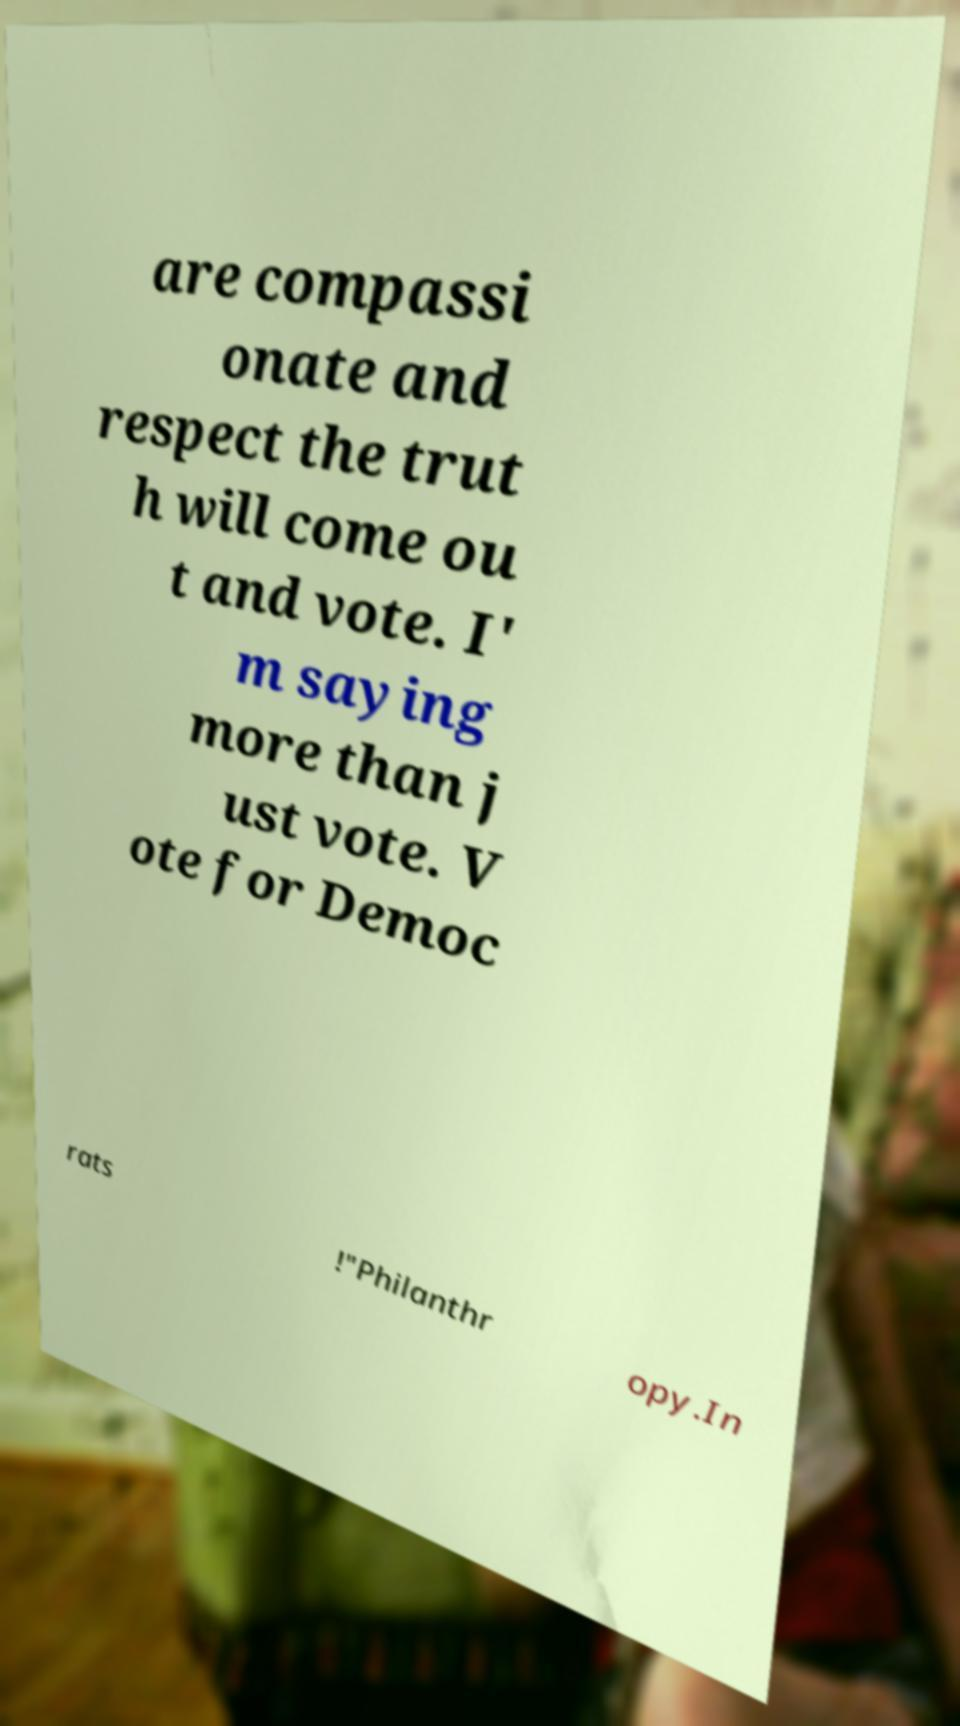Can you read and provide the text displayed in the image?This photo seems to have some interesting text. Can you extract and type it out for me? are compassi onate and respect the trut h will come ou t and vote. I' m saying more than j ust vote. V ote for Democ rats !"Philanthr opy.In 